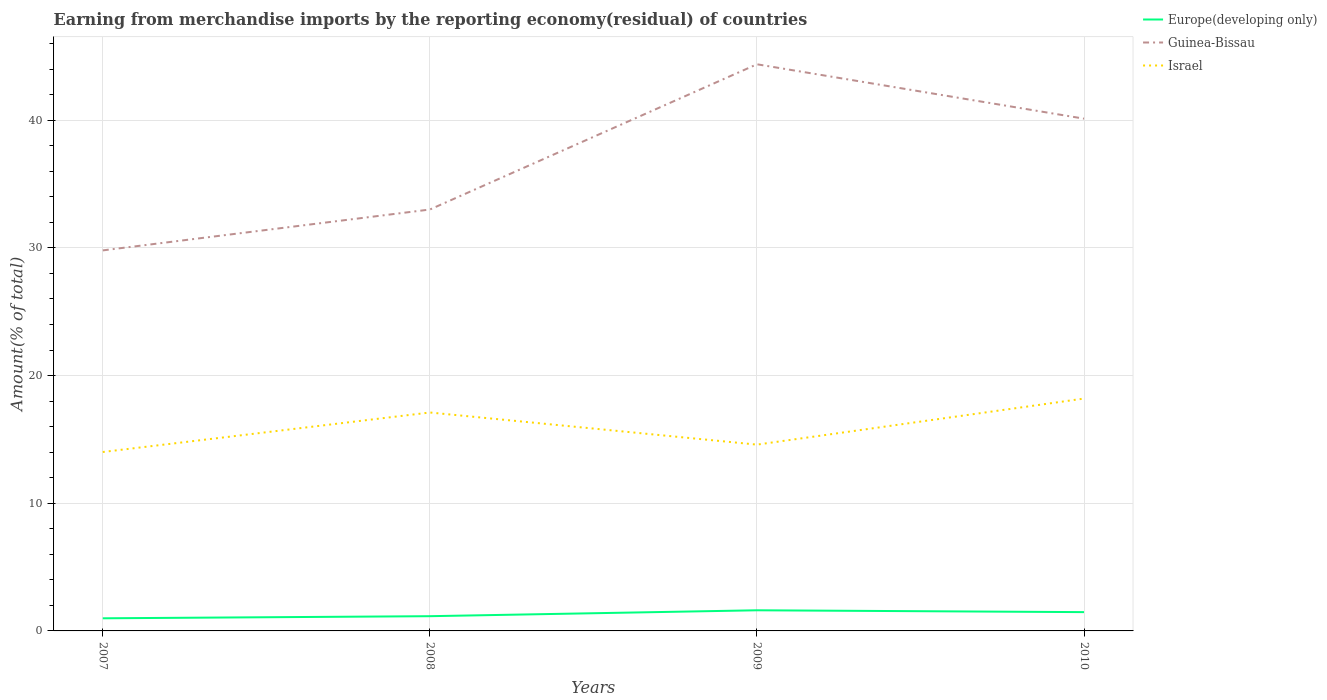Does the line corresponding to Israel intersect with the line corresponding to Europe(developing only)?
Ensure brevity in your answer.  No. Is the number of lines equal to the number of legend labels?
Your response must be concise. Yes. Across all years, what is the maximum percentage of amount earned from merchandise imports in Guinea-Bissau?
Your response must be concise. 29.81. In which year was the percentage of amount earned from merchandise imports in Israel maximum?
Make the answer very short. 2007. What is the total percentage of amount earned from merchandise imports in Europe(developing only) in the graph?
Your answer should be very brief. -0.63. What is the difference between the highest and the second highest percentage of amount earned from merchandise imports in Europe(developing only)?
Provide a succinct answer. 0.63. What is the difference between the highest and the lowest percentage of amount earned from merchandise imports in Israel?
Keep it short and to the point. 2. Is the percentage of amount earned from merchandise imports in Israel strictly greater than the percentage of amount earned from merchandise imports in Guinea-Bissau over the years?
Ensure brevity in your answer.  Yes. How many lines are there?
Provide a short and direct response. 3. How many years are there in the graph?
Provide a succinct answer. 4. What is the difference between two consecutive major ticks on the Y-axis?
Make the answer very short. 10. Does the graph contain any zero values?
Provide a short and direct response. No. Where does the legend appear in the graph?
Provide a short and direct response. Top right. How many legend labels are there?
Give a very brief answer. 3. What is the title of the graph?
Provide a short and direct response. Earning from merchandise imports by the reporting economy(residual) of countries. What is the label or title of the X-axis?
Offer a very short reply. Years. What is the label or title of the Y-axis?
Make the answer very short. Amount(% of total). What is the Amount(% of total) of Europe(developing only) in 2007?
Provide a short and direct response. 0.99. What is the Amount(% of total) in Guinea-Bissau in 2007?
Provide a succinct answer. 29.81. What is the Amount(% of total) of Israel in 2007?
Make the answer very short. 14.01. What is the Amount(% of total) of Europe(developing only) in 2008?
Offer a terse response. 1.15. What is the Amount(% of total) in Guinea-Bissau in 2008?
Offer a terse response. 33.01. What is the Amount(% of total) in Israel in 2008?
Make the answer very short. 17.11. What is the Amount(% of total) in Europe(developing only) in 2009?
Make the answer very short. 1.62. What is the Amount(% of total) of Guinea-Bissau in 2009?
Provide a succinct answer. 44.39. What is the Amount(% of total) in Israel in 2009?
Your answer should be compact. 14.59. What is the Amount(% of total) in Europe(developing only) in 2010?
Offer a very short reply. 1.47. What is the Amount(% of total) in Guinea-Bissau in 2010?
Provide a short and direct response. 40.13. What is the Amount(% of total) in Israel in 2010?
Offer a terse response. 18.2. Across all years, what is the maximum Amount(% of total) of Europe(developing only)?
Provide a succinct answer. 1.62. Across all years, what is the maximum Amount(% of total) in Guinea-Bissau?
Your response must be concise. 44.39. Across all years, what is the maximum Amount(% of total) in Israel?
Provide a short and direct response. 18.2. Across all years, what is the minimum Amount(% of total) in Europe(developing only)?
Give a very brief answer. 0.99. Across all years, what is the minimum Amount(% of total) in Guinea-Bissau?
Your response must be concise. 29.81. Across all years, what is the minimum Amount(% of total) of Israel?
Your response must be concise. 14.01. What is the total Amount(% of total) of Europe(developing only) in the graph?
Your answer should be very brief. 5.23. What is the total Amount(% of total) in Guinea-Bissau in the graph?
Offer a terse response. 147.33. What is the total Amount(% of total) in Israel in the graph?
Your answer should be compact. 63.92. What is the difference between the Amount(% of total) of Europe(developing only) in 2007 and that in 2008?
Keep it short and to the point. -0.17. What is the difference between the Amount(% of total) in Guinea-Bissau in 2007 and that in 2008?
Your response must be concise. -3.2. What is the difference between the Amount(% of total) in Israel in 2007 and that in 2008?
Give a very brief answer. -3.09. What is the difference between the Amount(% of total) of Europe(developing only) in 2007 and that in 2009?
Keep it short and to the point. -0.63. What is the difference between the Amount(% of total) in Guinea-Bissau in 2007 and that in 2009?
Offer a very short reply. -14.58. What is the difference between the Amount(% of total) in Israel in 2007 and that in 2009?
Offer a terse response. -0.58. What is the difference between the Amount(% of total) of Europe(developing only) in 2007 and that in 2010?
Your response must be concise. -0.48. What is the difference between the Amount(% of total) in Guinea-Bissau in 2007 and that in 2010?
Keep it short and to the point. -10.32. What is the difference between the Amount(% of total) in Israel in 2007 and that in 2010?
Ensure brevity in your answer.  -4.19. What is the difference between the Amount(% of total) in Europe(developing only) in 2008 and that in 2009?
Offer a terse response. -0.46. What is the difference between the Amount(% of total) in Guinea-Bissau in 2008 and that in 2009?
Your response must be concise. -11.38. What is the difference between the Amount(% of total) of Israel in 2008 and that in 2009?
Keep it short and to the point. 2.52. What is the difference between the Amount(% of total) in Europe(developing only) in 2008 and that in 2010?
Your response must be concise. -0.32. What is the difference between the Amount(% of total) in Guinea-Bissau in 2008 and that in 2010?
Provide a short and direct response. -7.12. What is the difference between the Amount(% of total) of Israel in 2008 and that in 2010?
Provide a short and direct response. -1.09. What is the difference between the Amount(% of total) in Europe(developing only) in 2009 and that in 2010?
Keep it short and to the point. 0.14. What is the difference between the Amount(% of total) in Guinea-Bissau in 2009 and that in 2010?
Provide a short and direct response. 4.26. What is the difference between the Amount(% of total) of Israel in 2009 and that in 2010?
Give a very brief answer. -3.61. What is the difference between the Amount(% of total) in Europe(developing only) in 2007 and the Amount(% of total) in Guinea-Bissau in 2008?
Offer a very short reply. -32.02. What is the difference between the Amount(% of total) in Europe(developing only) in 2007 and the Amount(% of total) in Israel in 2008?
Offer a very short reply. -16.12. What is the difference between the Amount(% of total) in Guinea-Bissau in 2007 and the Amount(% of total) in Israel in 2008?
Ensure brevity in your answer.  12.7. What is the difference between the Amount(% of total) of Europe(developing only) in 2007 and the Amount(% of total) of Guinea-Bissau in 2009?
Ensure brevity in your answer.  -43.4. What is the difference between the Amount(% of total) in Europe(developing only) in 2007 and the Amount(% of total) in Israel in 2009?
Offer a terse response. -13.6. What is the difference between the Amount(% of total) in Guinea-Bissau in 2007 and the Amount(% of total) in Israel in 2009?
Provide a succinct answer. 15.21. What is the difference between the Amount(% of total) of Europe(developing only) in 2007 and the Amount(% of total) of Guinea-Bissau in 2010?
Provide a short and direct response. -39.14. What is the difference between the Amount(% of total) of Europe(developing only) in 2007 and the Amount(% of total) of Israel in 2010?
Provide a succinct answer. -17.21. What is the difference between the Amount(% of total) in Guinea-Bissau in 2007 and the Amount(% of total) in Israel in 2010?
Your response must be concise. 11.61. What is the difference between the Amount(% of total) of Europe(developing only) in 2008 and the Amount(% of total) of Guinea-Bissau in 2009?
Offer a very short reply. -43.23. What is the difference between the Amount(% of total) of Europe(developing only) in 2008 and the Amount(% of total) of Israel in 2009?
Offer a terse response. -13.44. What is the difference between the Amount(% of total) of Guinea-Bissau in 2008 and the Amount(% of total) of Israel in 2009?
Your answer should be very brief. 18.42. What is the difference between the Amount(% of total) in Europe(developing only) in 2008 and the Amount(% of total) in Guinea-Bissau in 2010?
Your answer should be compact. -38.97. What is the difference between the Amount(% of total) of Europe(developing only) in 2008 and the Amount(% of total) of Israel in 2010?
Give a very brief answer. -17.05. What is the difference between the Amount(% of total) of Guinea-Bissau in 2008 and the Amount(% of total) of Israel in 2010?
Make the answer very short. 14.81. What is the difference between the Amount(% of total) of Europe(developing only) in 2009 and the Amount(% of total) of Guinea-Bissau in 2010?
Ensure brevity in your answer.  -38.51. What is the difference between the Amount(% of total) in Europe(developing only) in 2009 and the Amount(% of total) in Israel in 2010?
Provide a short and direct response. -16.58. What is the difference between the Amount(% of total) of Guinea-Bissau in 2009 and the Amount(% of total) of Israel in 2010?
Your answer should be very brief. 26.18. What is the average Amount(% of total) of Europe(developing only) per year?
Keep it short and to the point. 1.31. What is the average Amount(% of total) in Guinea-Bissau per year?
Your answer should be very brief. 36.83. What is the average Amount(% of total) in Israel per year?
Offer a terse response. 15.98. In the year 2007, what is the difference between the Amount(% of total) in Europe(developing only) and Amount(% of total) in Guinea-Bissau?
Provide a succinct answer. -28.82. In the year 2007, what is the difference between the Amount(% of total) of Europe(developing only) and Amount(% of total) of Israel?
Provide a succinct answer. -13.03. In the year 2007, what is the difference between the Amount(% of total) in Guinea-Bissau and Amount(% of total) in Israel?
Your answer should be compact. 15.79. In the year 2008, what is the difference between the Amount(% of total) of Europe(developing only) and Amount(% of total) of Guinea-Bissau?
Keep it short and to the point. -31.85. In the year 2008, what is the difference between the Amount(% of total) in Europe(developing only) and Amount(% of total) in Israel?
Your answer should be compact. -15.96. In the year 2008, what is the difference between the Amount(% of total) in Guinea-Bissau and Amount(% of total) in Israel?
Offer a terse response. 15.9. In the year 2009, what is the difference between the Amount(% of total) of Europe(developing only) and Amount(% of total) of Guinea-Bissau?
Offer a very short reply. -42.77. In the year 2009, what is the difference between the Amount(% of total) in Europe(developing only) and Amount(% of total) in Israel?
Your answer should be very brief. -12.98. In the year 2009, what is the difference between the Amount(% of total) of Guinea-Bissau and Amount(% of total) of Israel?
Give a very brief answer. 29.79. In the year 2010, what is the difference between the Amount(% of total) in Europe(developing only) and Amount(% of total) in Guinea-Bissau?
Ensure brevity in your answer.  -38.65. In the year 2010, what is the difference between the Amount(% of total) in Europe(developing only) and Amount(% of total) in Israel?
Your answer should be compact. -16.73. In the year 2010, what is the difference between the Amount(% of total) in Guinea-Bissau and Amount(% of total) in Israel?
Offer a terse response. 21.92. What is the ratio of the Amount(% of total) of Europe(developing only) in 2007 to that in 2008?
Make the answer very short. 0.86. What is the ratio of the Amount(% of total) in Guinea-Bissau in 2007 to that in 2008?
Your answer should be compact. 0.9. What is the ratio of the Amount(% of total) in Israel in 2007 to that in 2008?
Your answer should be very brief. 0.82. What is the ratio of the Amount(% of total) of Europe(developing only) in 2007 to that in 2009?
Your answer should be very brief. 0.61. What is the ratio of the Amount(% of total) in Guinea-Bissau in 2007 to that in 2009?
Give a very brief answer. 0.67. What is the ratio of the Amount(% of total) of Israel in 2007 to that in 2009?
Your answer should be compact. 0.96. What is the ratio of the Amount(% of total) in Europe(developing only) in 2007 to that in 2010?
Provide a short and direct response. 0.67. What is the ratio of the Amount(% of total) of Guinea-Bissau in 2007 to that in 2010?
Provide a succinct answer. 0.74. What is the ratio of the Amount(% of total) of Israel in 2007 to that in 2010?
Give a very brief answer. 0.77. What is the ratio of the Amount(% of total) in Europe(developing only) in 2008 to that in 2009?
Provide a short and direct response. 0.71. What is the ratio of the Amount(% of total) of Guinea-Bissau in 2008 to that in 2009?
Your answer should be compact. 0.74. What is the ratio of the Amount(% of total) in Israel in 2008 to that in 2009?
Provide a succinct answer. 1.17. What is the ratio of the Amount(% of total) of Europe(developing only) in 2008 to that in 2010?
Provide a succinct answer. 0.78. What is the ratio of the Amount(% of total) in Guinea-Bissau in 2008 to that in 2010?
Provide a succinct answer. 0.82. What is the ratio of the Amount(% of total) of Israel in 2008 to that in 2010?
Make the answer very short. 0.94. What is the ratio of the Amount(% of total) of Europe(developing only) in 2009 to that in 2010?
Provide a succinct answer. 1.1. What is the ratio of the Amount(% of total) of Guinea-Bissau in 2009 to that in 2010?
Offer a terse response. 1.11. What is the ratio of the Amount(% of total) of Israel in 2009 to that in 2010?
Ensure brevity in your answer.  0.8. What is the difference between the highest and the second highest Amount(% of total) in Europe(developing only)?
Ensure brevity in your answer.  0.14. What is the difference between the highest and the second highest Amount(% of total) in Guinea-Bissau?
Give a very brief answer. 4.26. What is the difference between the highest and the second highest Amount(% of total) in Israel?
Ensure brevity in your answer.  1.09. What is the difference between the highest and the lowest Amount(% of total) of Europe(developing only)?
Ensure brevity in your answer.  0.63. What is the difference between the highest and the lowest Amount(% of total) of Guinea-Bissau?
Provide a short and direct response. 14.58. What is the difference between the highest and the lowest Amount(% of total) in Israel?
Keep it short and to the point. 4.19. 